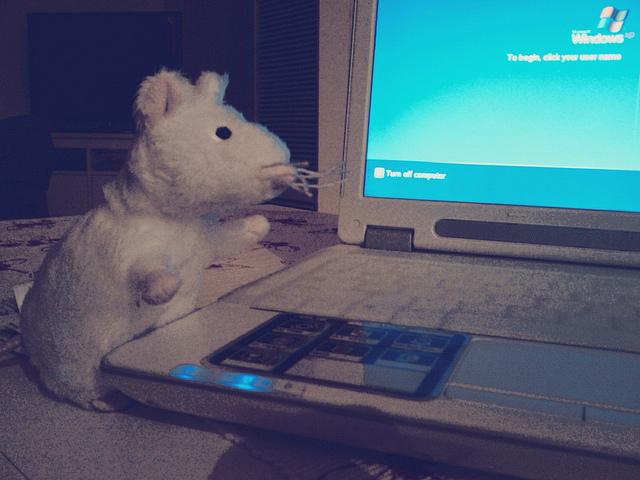Is the computer using an Apple operating system?
Answer briefly. No. Is the laptop on?
Short answer required. Yes. Is this mouse stuffed?
Concise answer only. Yes. 